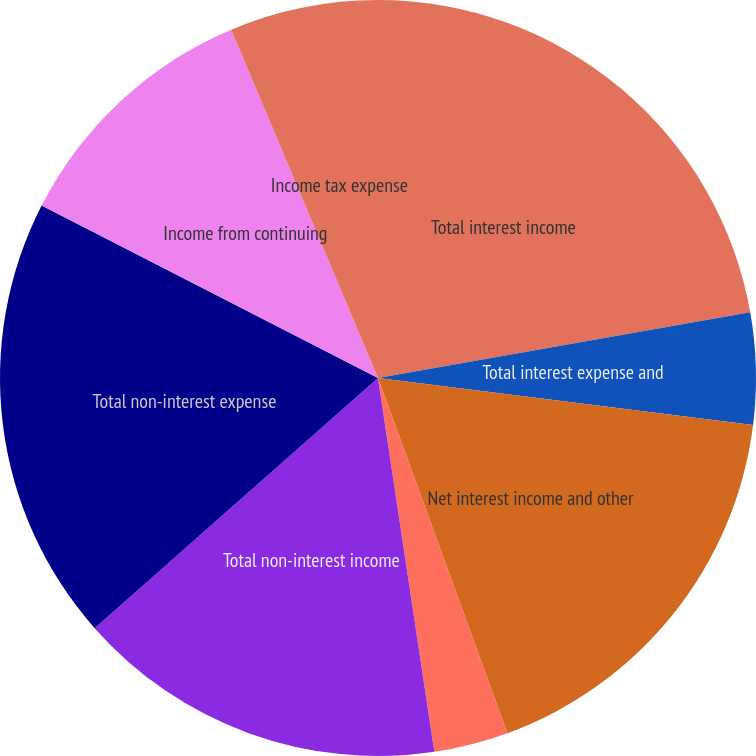Convert chart. <chart><loc_0><loc_0><loc_500><loc_500><pie_chart><fcel>Total interest income<fcel>Total interest expense and<fcel>Net interest income and other<fcel>Provision (credit) for loan<fcel>Total non-interest income<fcel>Total non-interest expense<fcel>Income from continuing<fcel>Income tax expense<nl><fcel>22.22%<fcel>4.76%<fcel>17.46%<fcel>3.18%<fcel>15.87%<fcel>19.05%<fcel>11.11%<fcel>6.35%<nl></chart> 